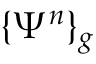<formula> <loc_0><loc_0><loc_500><loc_500>\{ \Psi ^ { n } \} _ { g }</formula> 